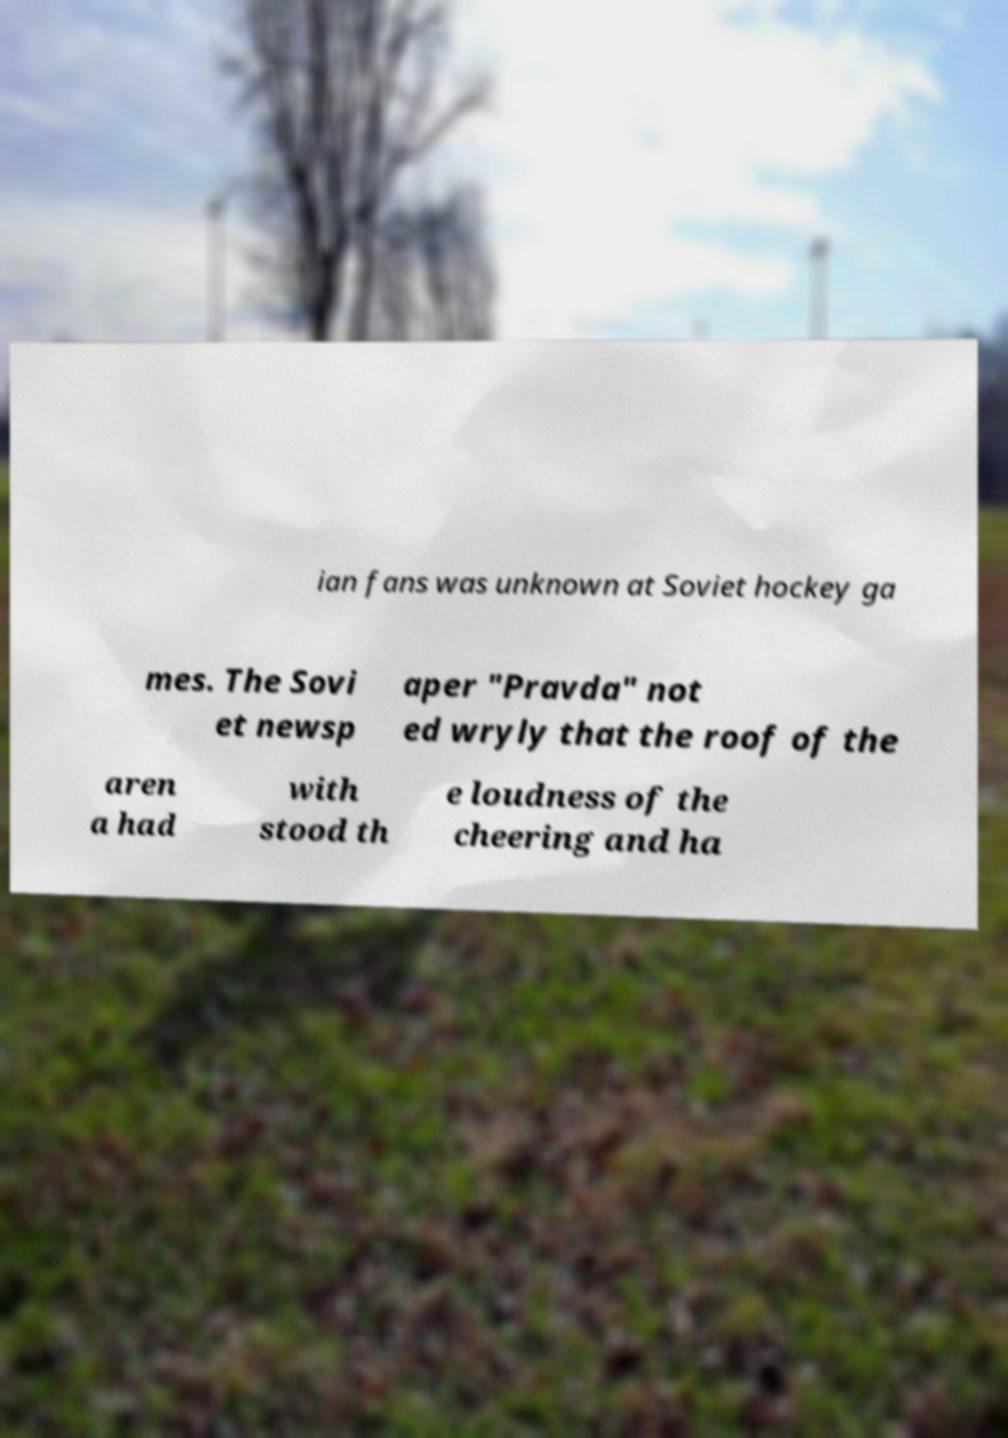Can you accurately transcribe the text from the provided image for me? ian fans was unknown at Soviet hockey ga mes. The Sovi et newsp aper "Pravda" not ed wryly that the roof of the aren a had with stood th e loudness of the cheering and ha 